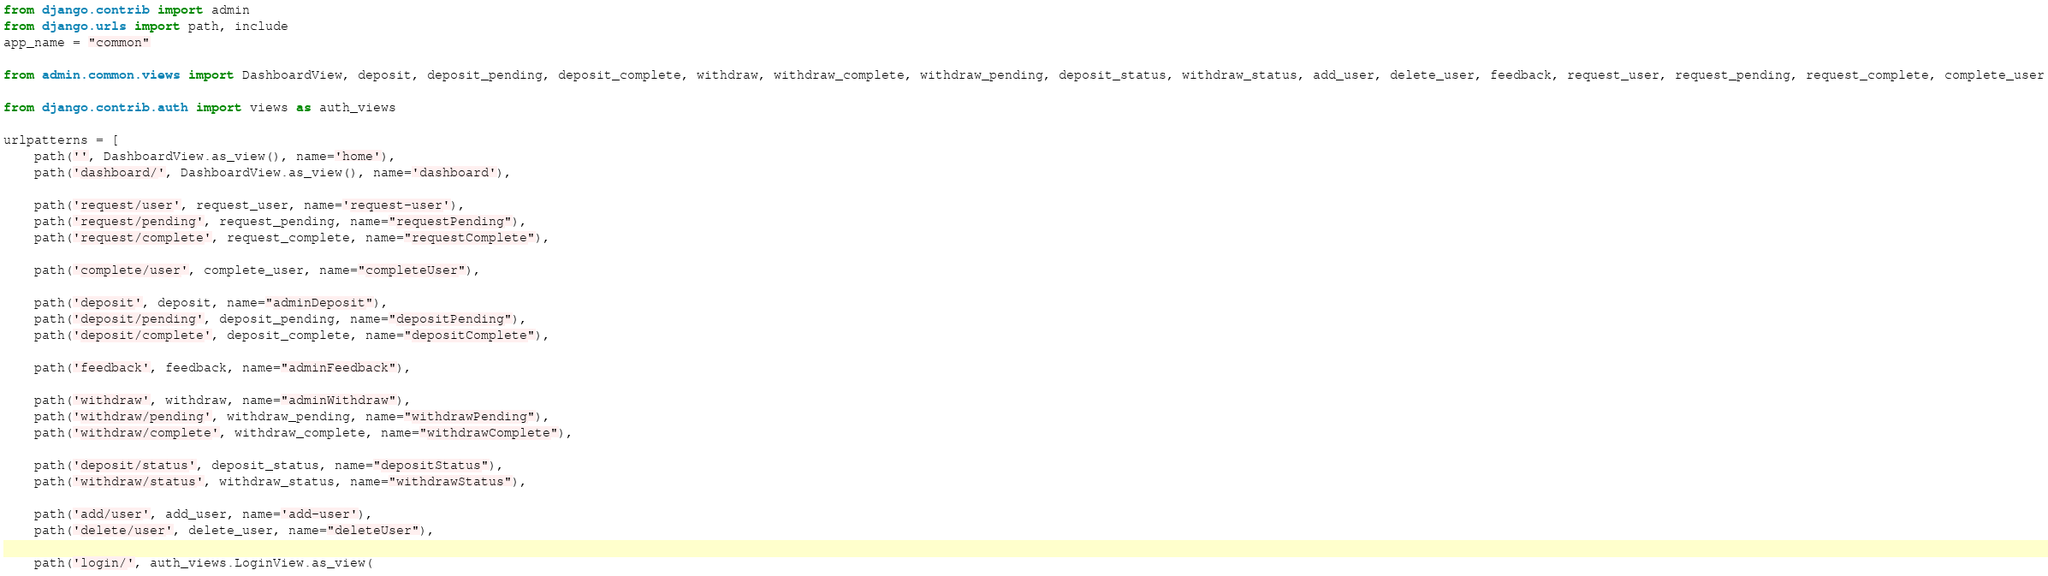<code> <loc_0><loc_0><loc_500><loc_500><_Python_>from django.contrib import admin
from django.urls import path, include
app_name = "common"

from admin.common.views import DashboardView, deposit, deposit_pending, deposit_complete, withdraw, withdraw_complete, withdraw_pending, deposit_status, withdraw_status, add_user, delete_user, feedback, request_user, request_pending, request_complete, complete_user

from django.contrib.auth import views as auth_views

urlpatterns = [    
    path('', DashboardView.as_view(), name='home'),
    path('dashboard/', DashboardView.as_view(), name='dashboard'),

    path('request/user', request_user, name='request-user'),
    path('request/pending', request_pending, name="requestPending"),
    path('request/complete', request_complete, name="requestComplete"),

    path('complete/user', complete_user, name="completeUser"),

    path('deposit', deposit, name="adminDeposit"),
    path('deposit/pending', deposit_pending, name="depositPending"),
    path('deposit/complete', deposit_complete, name="depositComplete"),

    path('feedback', feedback, name="adminFeedback"),

    path('withdraw', withdraw, name="adminWithdraw"),
    path('withdraw/pending', withdraw_pending, name="withdrawPending"),
    path('withdraw/complete', withdraw_complete, name="withdrawComplete"),

    path('deposit/status', deposit_status, name="depositStatus"),
    path('withdraw/status', withdraw_status, name="withdrawStatus"),

    path('add/user', add_user, name='add-user'),
    path('delete/user', delete_user, name="deleteUser"),

    path('login/', auth_views.LoginView.as_view(</code> 